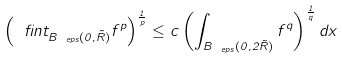Convert formula to latex. <formula><loc_0><loc_0><loc_500><loc_500>\left ( \ f i n t _ { B _ { \ e p s } ( 0 , \tilde { R } ) } f ^ { p } \right ) ^ { \frac { 1 } { p } } \leq c \left ( \int _ { B _ { \ e p s } ( 0 , 2 \tilde { R } ) } f ^ { q } \right ) ^ { \frac { 1 } { q } } d x</formula> 